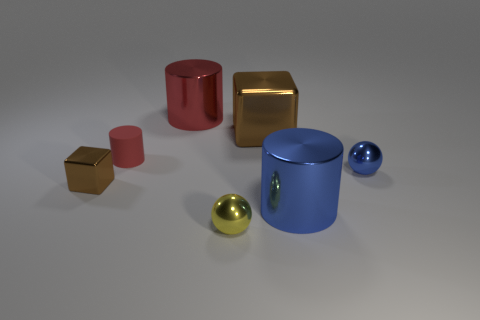There is a tiny shiny thing that is right of the small cylinder and on the left side of the large brown thing; what is its color?
Your answer should be compact. Yellow. Are there more matte things than gray metal objects?
Your answer should be very brief. Yes. How many objects are gray balls or things that are behind the tiny block?
Keep it short and to the point. 4. Do the blue sphere and the yellow metal sphere have the same size?
Ensure brevity in your answer.  Yes. Are there any brown metallic cubes in front of the blue cylinder?
Offer a very short reply. No. There is a thing that is in front of the small red matte object and on the left side of the tiny yellow ball; how big is it?
Your response must be concise. Small. What number of objects are tiny brown objects or big brown metal objects?
Offer a very short reply. 2. Is the size of the red rubber cylinder the same as the red thing that is on the right side of the tiny red object?
Your response must be concise. No. There is a cylinder in front of the small ball that is on the right side of the big cylinder that is in front of the small red matte cylinder; how big is it?
Keep it short and to the point. Large. Are there any tiny brown cubes?
Give a very brief answer. Yes. 